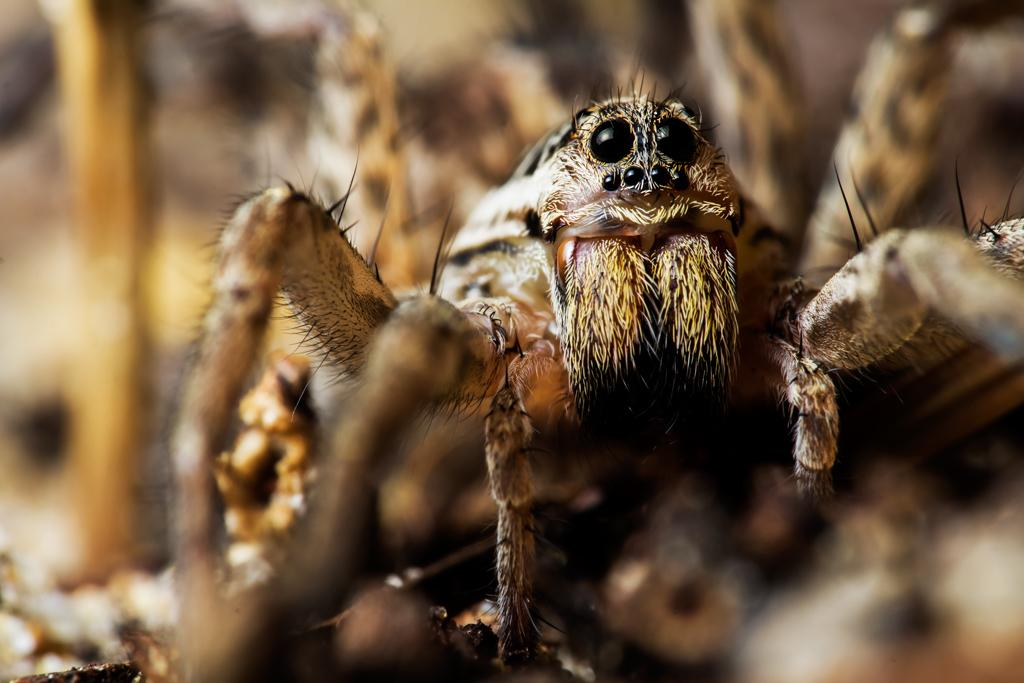What is the main subject of the image? There is a spider in the image. Can you describe the background of the image? The background of the image is blurry. What type of cloth is draped over the man in the image? There is no man or cloth present in the image; it features a spider with a blurry background. 